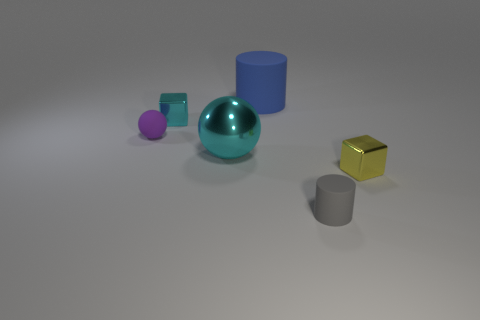There is a object that is the same color as the large metal ball; what is its material?
Your answer should be compact. Metal. Are there any purple things right of the tiny shiny block on the left side of the small metal block that is to the right of the tiny matte cylinder?
Your response must be concise. No. How many other objects are there of the same shape as the big blue thing?
Your answer should be very brief. 1. What color is the matte object that is behind the tiny metallic object behind the yellow block that is right of the gray thing?
Make the answer very short. Blue. How many tiny matte things are there?
Keep it short and to the point. 2. What number of large objects are either yellow metal blocks or metallic cubes?
Make the answer very short. 0. What is the shape of the yellow metal object that is the same size as the purple thing?
Make the answer very short. Cube. Is there any other thing that has the same size as the blue object?
Give a very brief answer. Yes. The cylinder that is to the left of the matte cylinder in front of the small rubber sphere is made of what material?
Offer a terse response. Rubber. Do the blue thing and the purple rubber sphere have the same size?
Ensure brevity in your answer.  No. 